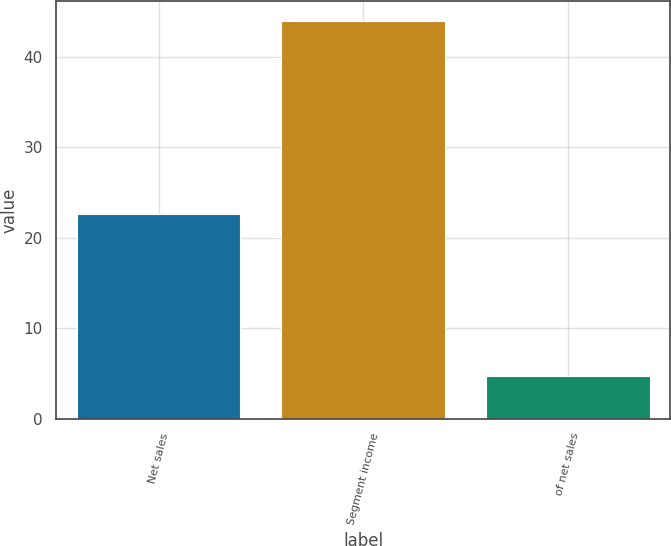<chart> <loc_0><loc_0><loc_500><loc_500><bar_chart><fcel>Net sales<fcel>Segment income<fcel>of net sales<nl><fcel>22.6<fcel>44<fcel>4.7<nl></chart> 